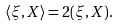<formula> <loc_0><loc_0><loc_500><loc_500>\langle \xi , X \rangle = 2 ( \xi , X ) .</formula> 